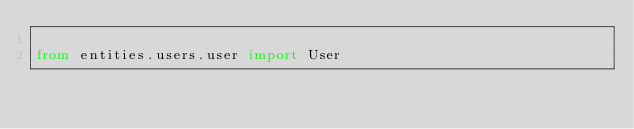<code> <loc_0><loc_0><loc_500><loc_500><_Python_>
from entities.users.user import User
</code> 